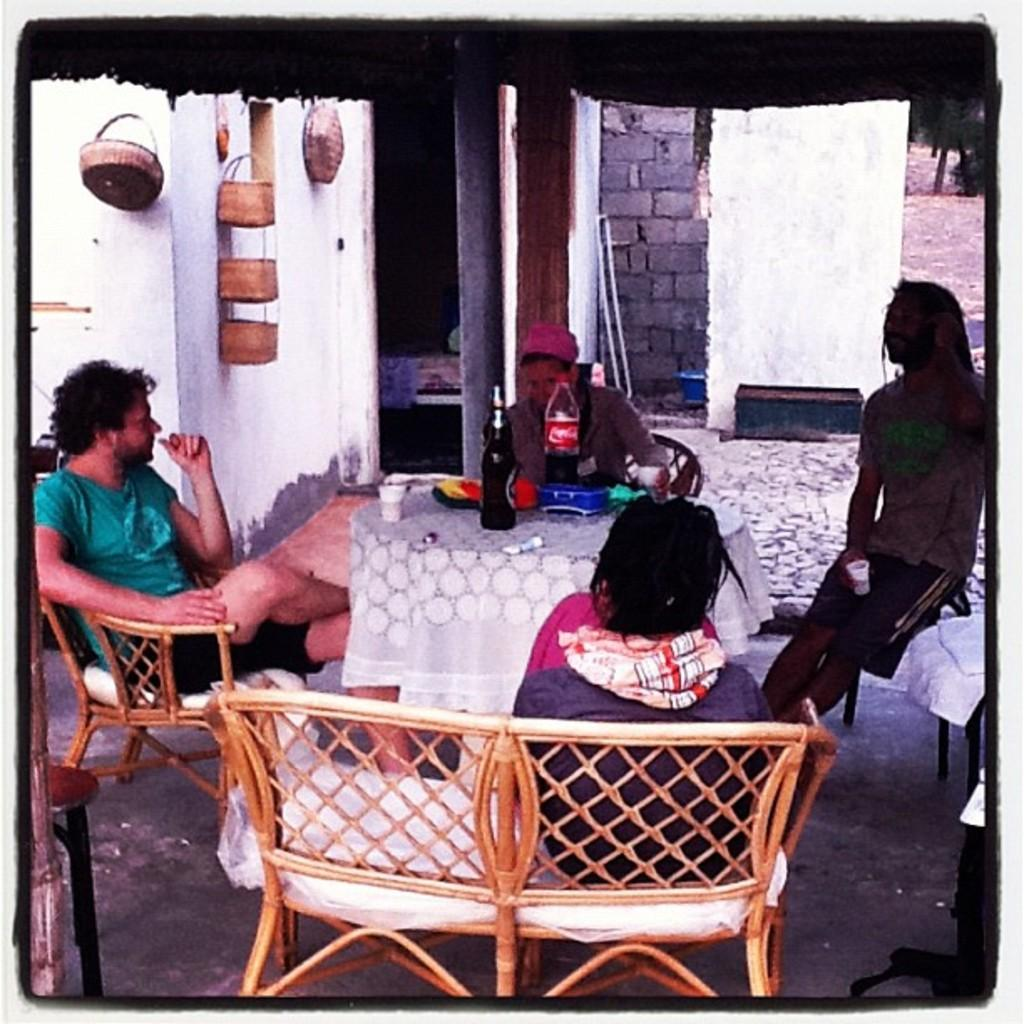How many people are sitting at the table in the image? There are 4 people sitting at the table. What are the people sitting on? The people are sitting on chairs. What can be seen on the table besides the people? There are water bottles and a wine bottle on the table. What else is on the table? There are caps on the table. What can be seen in the background of the image? There is a wall in the background. What type of crack is being served on the table in the image? There is no crack present on the table in the image. What is the current temperature in the room where the image was taken? The provided facts do not give any information about the temperature in the room, so it cannot be determined from the image. 